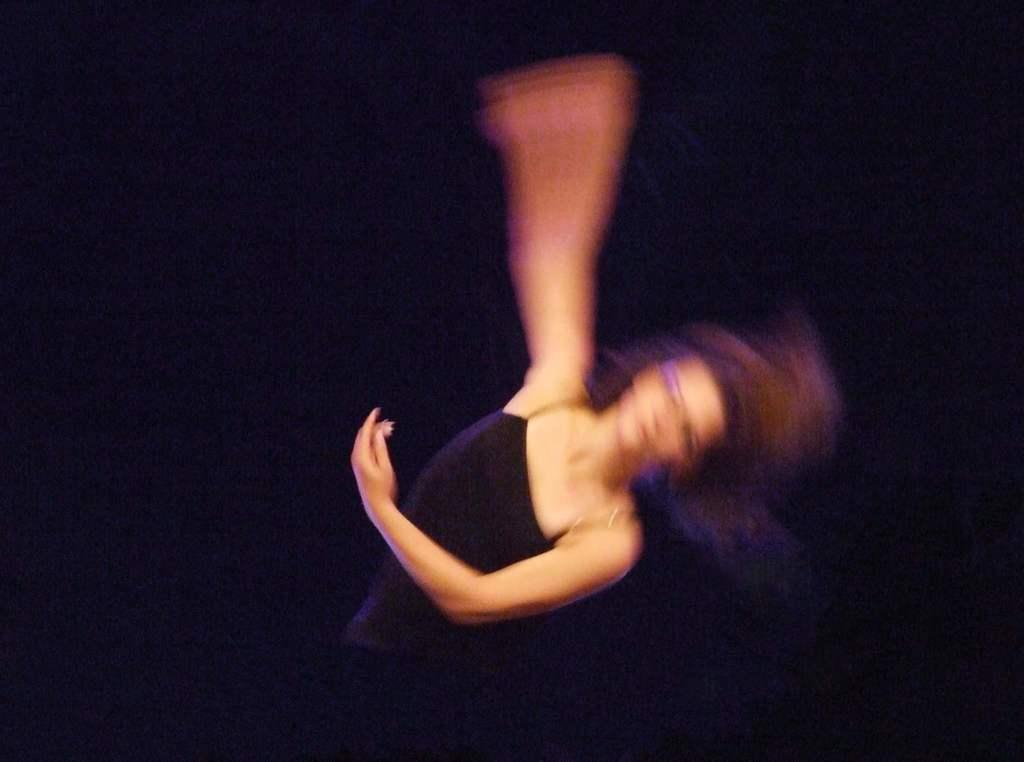What is the main subject of the image? There is a blurred person in the image. Can you describe the background of the image? The background of the image is dark. What type of peace symbol can be seen in the image? There is no peace symbol present in the image. Is there a church visible in the image? There is no church visible in the image. 